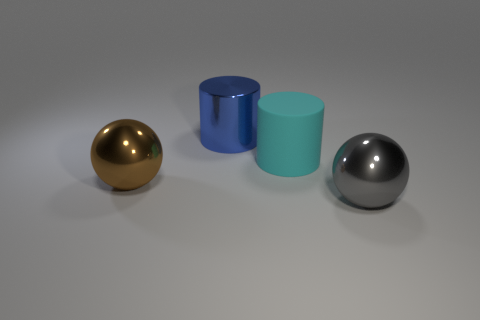The metallic cylinder is what color?
Keep it short and to the point. Blue. What is the material of the cyan object that is the same size as the gray ball?
Offer a terse response. Rubber. How big is the object that is both in front of the rubber object and on the right side of the metal cylinder?
Provide a short and direct response. Large. There is another shiny object that is the same shape as the brown thing; what is its size?
Offer a very short reply. Large. How many objects are either big blue metallic cylinders or objects right of the blue shiny cylinder?
Offer a very short reply. 3. What shape is the big cyan rubber object?
Keep it short and to the point. Cylinder. There is a large object on the right side of the cylinder to the right of the blue cylinder; what shape is it?
Your answer should be compact. Sphere. There is a cylinder that is made of the same material as the gray sphere; what color is it?
Provide a short and direct response. Blue. Are there any other things that are the same size as the blue shiny object?
Your answer should be very brief. Yes. Is the color of the big shiny ball that is behind the gray metallic sphere the same as the large object that is behind the large cyan rubber cylinder?
Your answer should be very brief. No. 